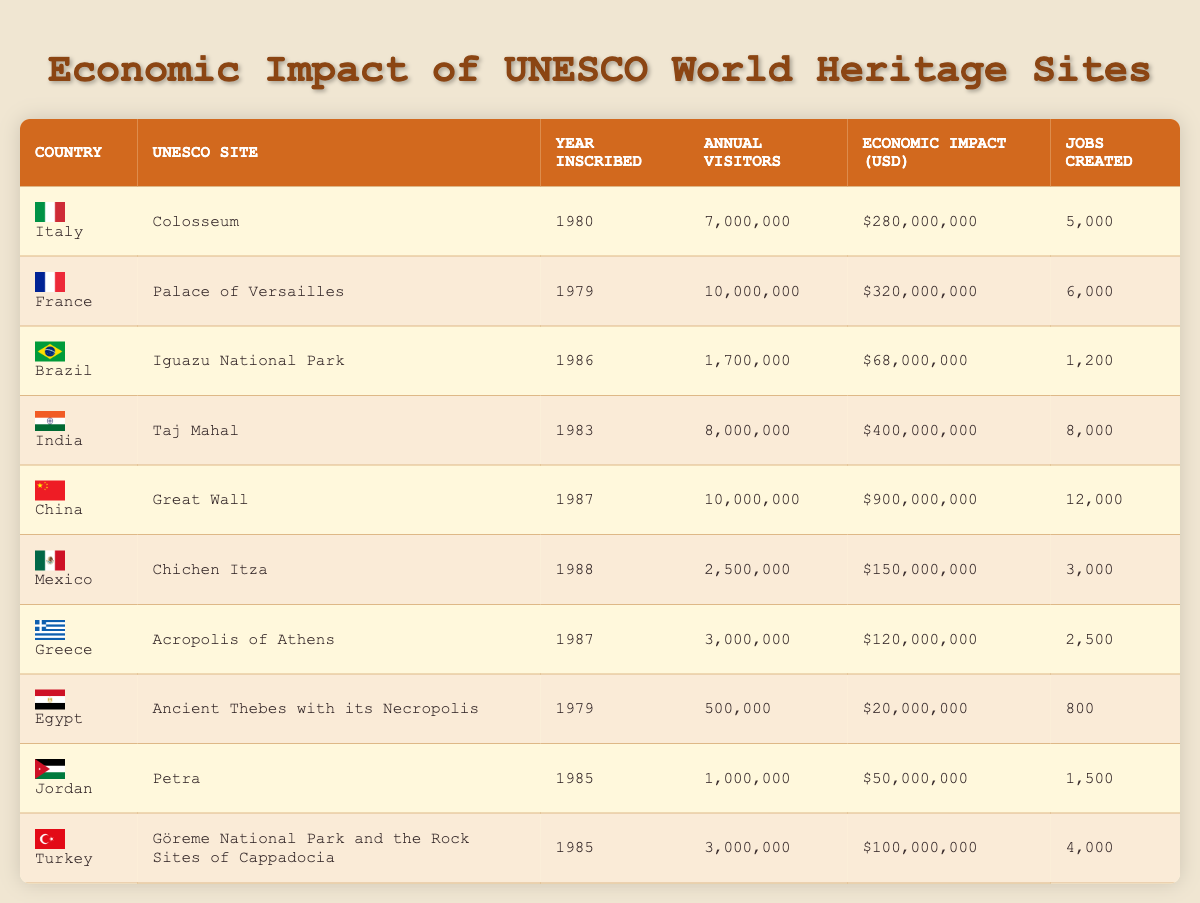What is the highest economic impact reported for a UNESCO World Heritage site? The table shows that the Great Wall in China has an economic impact of $900,000,000, which is higher than any other site listed.
Answer: $900,000,000 Which country has the most jobs created from its UNESCO site? The Great Wall in China has created 12,000 jobs, the highest reported in the table.
Answer: 12,000 What is the total number of annual visitors for all listed UNESCO sites? To find the total, we sum the annual visitors: (7,000,000 + 10,000,000 + 1,700,000 + 8,000,000 + 10,000,000 + 2,500,000 + 3,000,000 + 500,000 + 1,000,000 + 3,000,000) = 47,700,000.
Answer: 47,700,000 Is the economic impact of the Taj Mahal greater than that of Chichen Itza? The economic impact of the Taj Mahal is $400,000,000 and that of Chichen Itza is $150,000,000; since $400,000,000 is greater than $150,000,000, the statement is true.
Answer: Yes What is the average number of annual visitors across all UNESCO sites listed? The total number of annual visitors is 47,700,000, and there are 10 sites, so the average is 47,700,000 / 10 = 4,770,000.
Answer: 4,770,000 How many jobs were created across all UNESCO sites in total? To find the total number of jobs, we sum the jobs created: (5000 + 6000 + 1200 + 8000 + 12000 + 3000 + 2500 + 800 + 1500 + 4000) = 40,000.
Answer: 40,000 Which site from Greece has the lowest economic impact compared to other UNESCO sites? The Acropolis of Athens has an economic impact of $120,000,000, which is lower than all other sites listed in the table.
Answer: $120,000,000 Is the annual visitor count for Chichen Itza more than that for the Taj Mahal? Chichen Itza has 2,500,000 visitors while the Taj Mahal has 8,000,000. Therefore, Chichen Itza has fewer visitors than the Taj Mahal.
Answer: No Out of the sites listed, which two had the highest visitor statistics? The Palace of Versailles (10,000,000) and the Great Wall (10,000,000) both had the highest visitor statistics, tying for first place.
Answer: Palace of Versailles and Great Wall What is the difference in economic impact between the Great Wall and the Taj Mahal? The Great Wall has an economic impact of $900,000,000 and the Taj Mahal $400,000,000. The difference is $900,000,000 - $400,000,000 = $500,000,000.
Answer: $500,000,000 